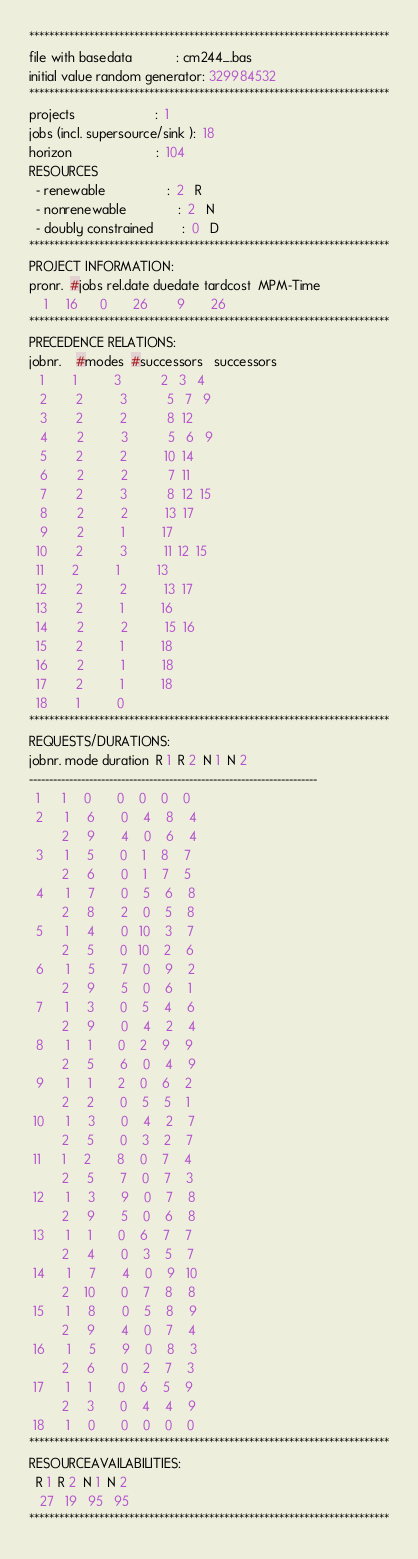Convert code to text. <code><loc_0><loc_0><loc_500><loc_500><_ObjectiveC_>************************************************************************
file with basedata            : cm244_.bas
initial value random generator: 329984532
************************************************************************
projects                      :  1
jobs (incl. supersource/sink ):  18
horizon                       :  104
RESOURCES
  - renewable                 :  2   R
  - nonrenewable              :  2   N
  - doubly constrained        :  0   D
************************************************************************
PROJECT INFORMATION:
pronr.  #jobs rel.date duedate tardcost  MPM-Time
    1     16      0       26        9       26
************************************************************************
PRECEDENCE RELATIONS:
jobnr.    #modes  #successors   successors
   1        1          3           2   3   4
   2        2          3           5   7   9
   3        2          2           8  12
   4        2          3           5   6   9
   5        2          2          10  14
   6        2          2           7  11
   7        2          3           8  12  15
   8        2          2          13  17
   9        2          1          17
  10        2          3          11  12  15
  11        2          1          13
  12        2          2          13  17
  13        2          1          16
  14        2          2          15  16
  15        2          1          18
  16        2          1          18
  17        2          1          18
  18        1          0        
************************************************************************
REQUESTS/DURATIONS:
jobnr. mode duration  R 1  R 2  N 1  N 2
------------------------------------------------------------------------
  1      1     0       0    0    0    0
  2      1     6       0    4    8    4
         2     9       4    0    6    4
  3      1     5       0    1    8    7
         2     6       0    1    7    5
  4      1     7       0    5    6    8
         2     8       2    0    5    8
  5      1     4       0   10    3    7
         2     5       0   10    2    6
  6      1     5       7    0    9    2
         2     9       5    0    6    1
  7      1     3       0    5    4    6
         2     9       0    4    2    4
  8      1     1       0    2    9    9
         2     5       6    0    4    9
  9      1     1       2    0    6    2
         2     2       0    5    5    1
 10      1     3       0    4    2    7
         2     5       0    3    2    7
 11      1     2       8    0    7    4
         2     5       7    0    7    3
 12      1     3       9    0    7    8
         2     9       5    0    6    8
 13      1     1       0    6    7    7
         2     4       0    3    5    7
 14      1     7       4    0    9   10
         2    10       0    7    8    8
 15      1     8       0    5    8    9
         2     9       4    0    7    4
 16      1     5       9    0    8    3
         2     6       0    2    7    3
 17      1     1       0    6    5    9
         2     3       0    4    4    9
 18      1     0       0    0    0    0
************************************************************************
RESOURCEAVAILABILITIES:
  R 1  R 2  N 1  N 2
   27   19   95   95
************************************************************************
</code> 